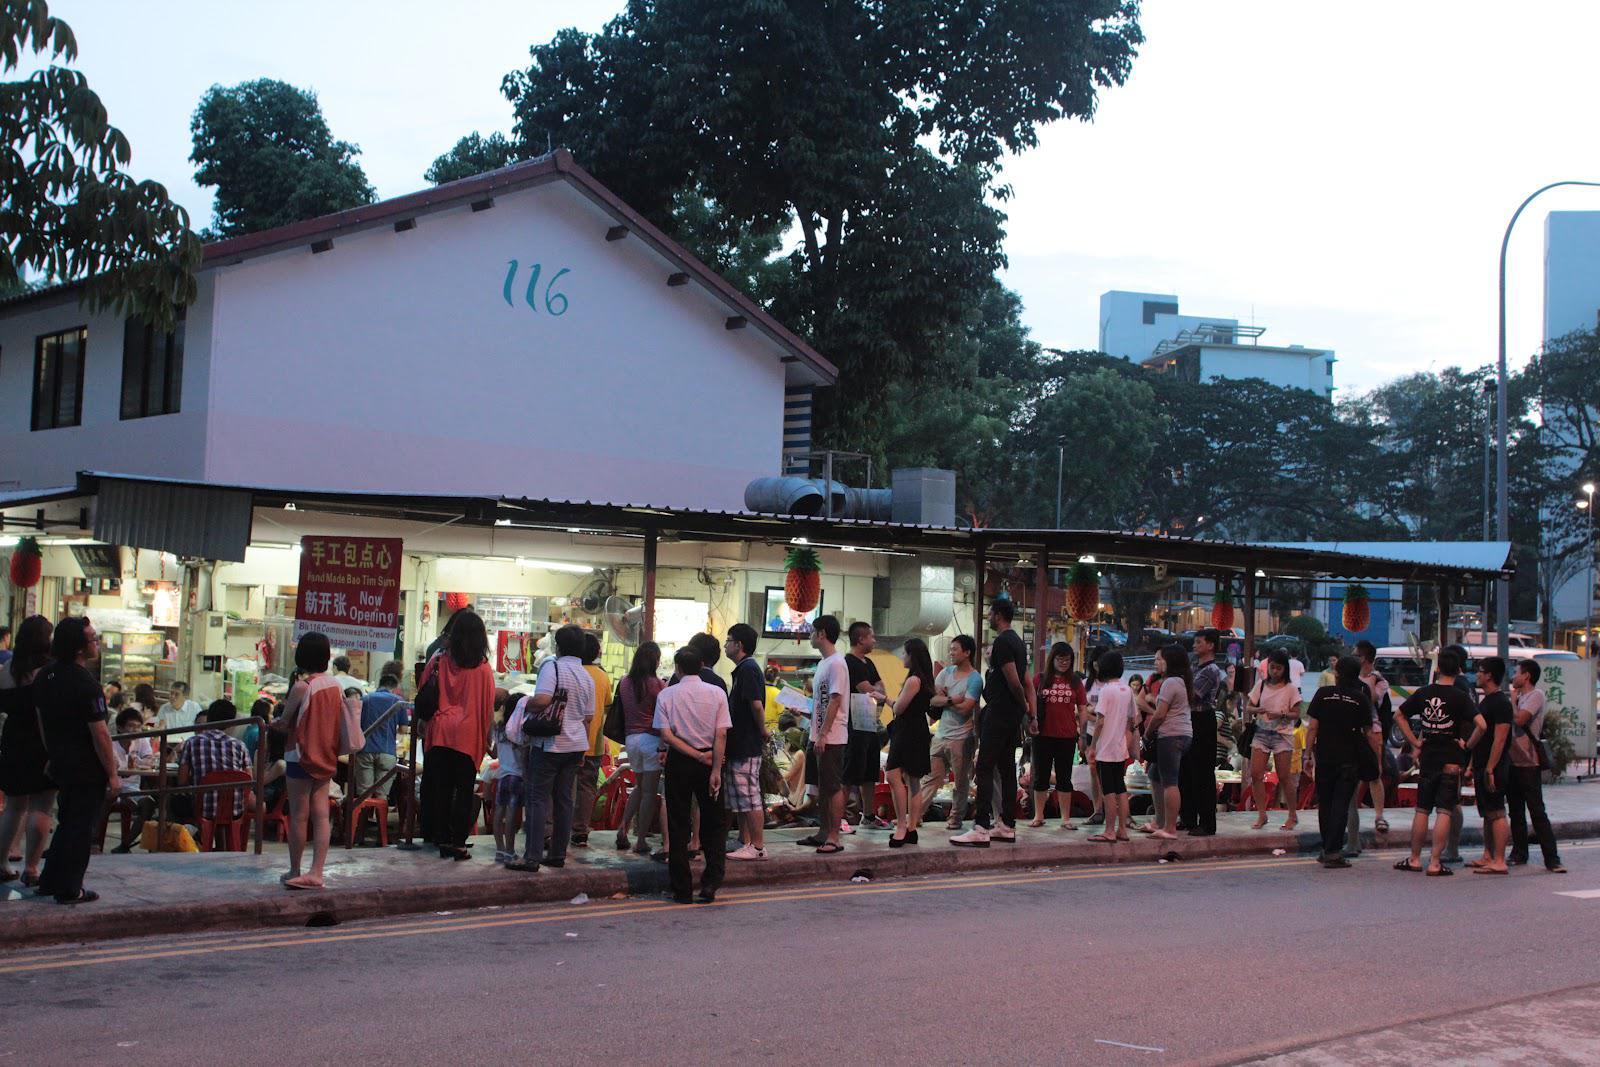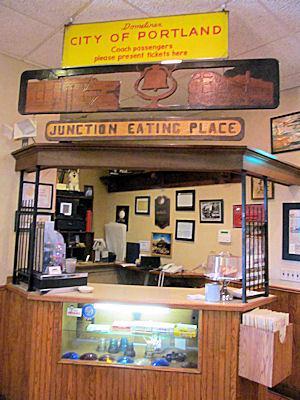The first image is the image on the left, the second image is the image on the right. Analyze the images presented: Is the assertion "One image shows a flat-topped building with a sign lettered in two colors above a row of six rectangular windows." valid? Answer yes or no. No. The first image is the image on the left, the second image is the image on the right. Evaluate the accuracy of this statement regarding the images: "The image shows the outside of a restaurant with it's name displayed near the top of the building". Is it true? Answer yes or no. No. 